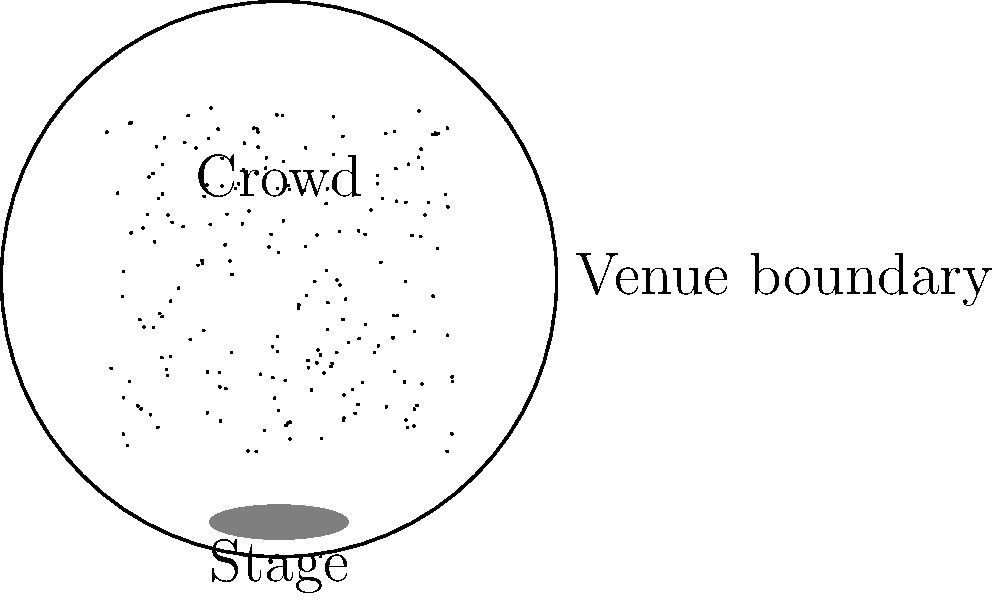As a seasoned jazz musician familiar with Greenwich Village venues, you're helping develop a machine learning model to estimate crowd sizes from aerial photographs. Given the aerial view of a circular venue with a radius of 50 feet, how would you estimate the crowd size if the average person occupies a 4 square foot area? Assume uniform distribution and that 80% of the venue area is occupied by the audience. Let's approach this step-by-step:

1) First, we need to calculate the total area of the venue:
   Area of a circle = $\pi r^2$
   Area = $\pi \times 50^2 = 7,853.98$ sq ft

2) Now, we consider that only 80% of this area is occupied by the audience:
   Occupied area = $7,853.98 \times 0.8 = 6,283.19$ sq ft

3) Given that each person occupies 4 sq ft on average, we can estimate the number of people:
   Number of people = Occupied area / Area per person
   Number of people = $6,283.19 / 4 = 1,570.80$

4) Since we can't have a fractional number of people, we round down to the nearest whole number:
   Estimated crowd size = 1,570 people

This method provides a reasonable estimate based on the given information. However, it's important to note that real-world scenarios might have variations in crowd density and distribution.
Answer: 1,570 people 